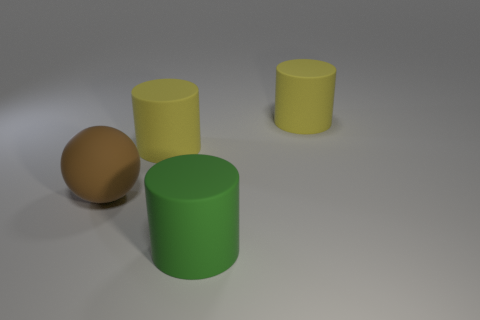Subtract 1 cylinders. How many cylinders are left? 2 Add 2 cylinders. How many objects exist? 6 Subtract all cylinders. How many objects are left? 1 Add 1 small brown spheres. How many small brown spheres exist? 1 Subtract 0 green spheres. How many objects are left? 4 Subtract all yellow rubber cylinders. Subtract all big green cylinders. How many objects are left? 1 Add 2 big rubber cylinders. How many big rubber cylinders are left? 5 